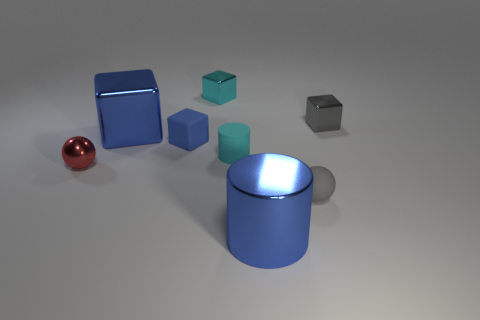Subtract all small matte cubes. How many cubes are left? 3 Subtract all cyan cylinders. How many cylinders are left? 1 Add 2 red metallic things. How many objects exist? 10 Subtract all gray cylinders. How many blue blocks are left? 2 Subtract all cylinders. How many objects are left? 6 Subtract 1 cubes. How many cubes are left? 3 Add 2 gray metal cubes. How many gray metal cubes are left? 3 Add 6 big metallic cubes. How many big metallic cubes exist? 7 Subtract 0 brown balls. How many objects are left? 8 Subtract all red cylinders. Subtract all cyan balls. How many cylinders are left? 2 